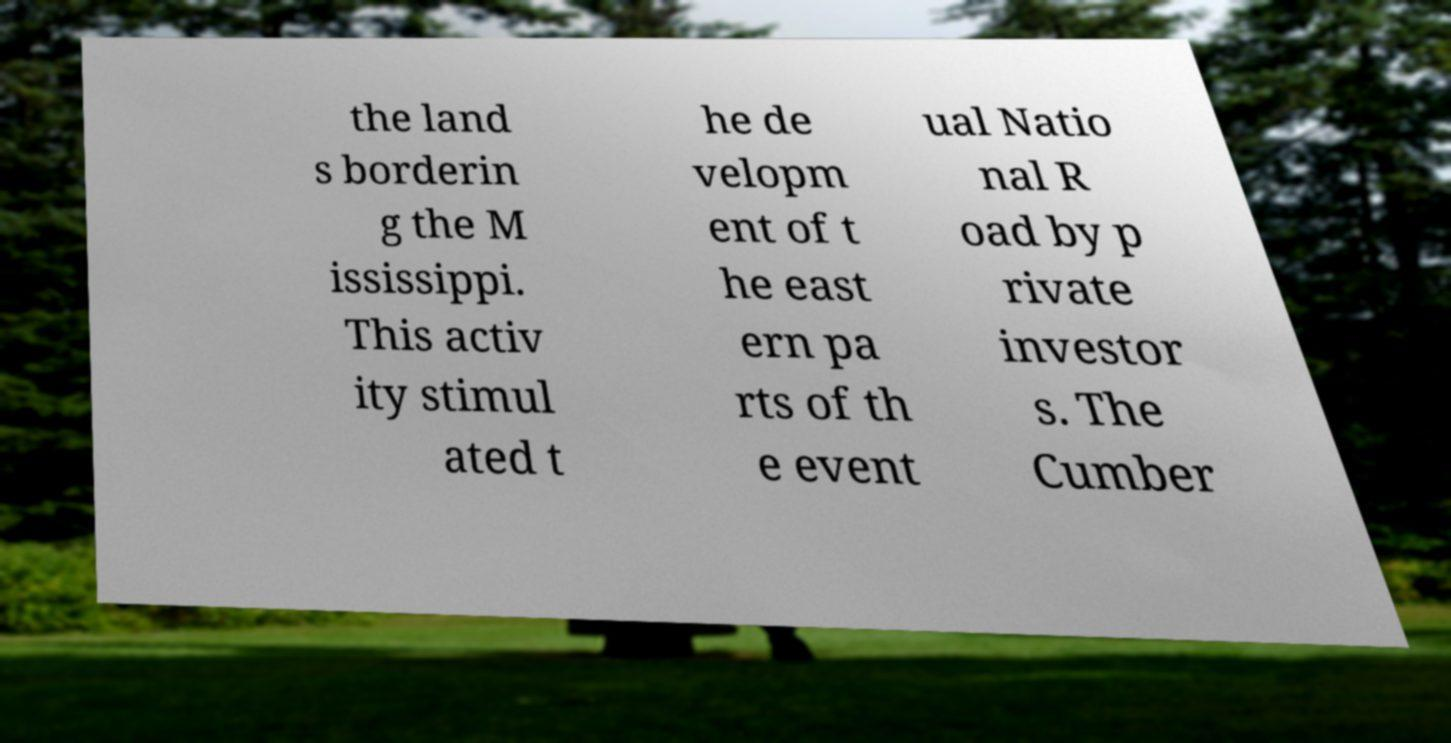Could you assist in decoding the text presented in this image and type it out clearly? the land s borderin g the M ississippi. This activ ity stimul ated t he de velopm ent of t he east ern pa rts of th e event ual Natio nal R oad by p rivate investor s. The Cumber 